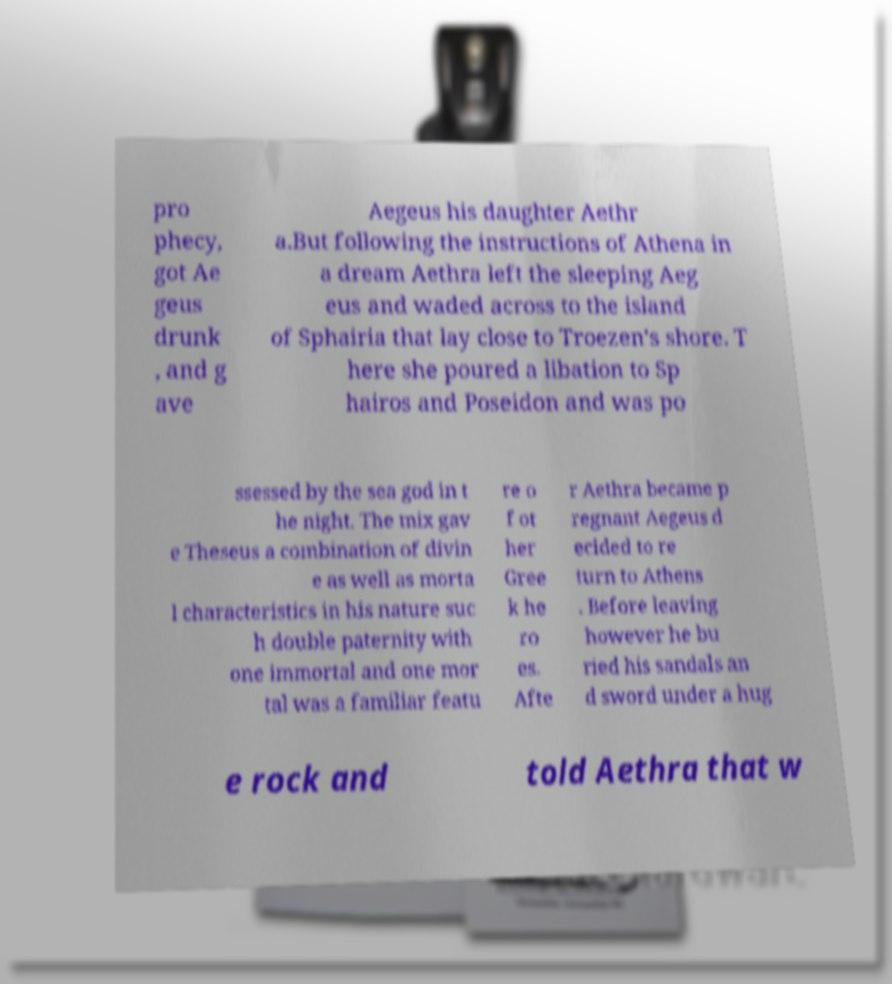What messages or text are displayed in this image? I need them in a readable, typed format. pro phecy, got Ae geus drunk , and g ave Aegeus his daughter Aethr a.But following the instructions of Athena in a dream Aethra left the sleeping Aeg eus and waded across to the island of Sphairia that lay close to Troezen's shore. T here she poured a libation to Sp hairos and Poseidon and was po ssessed by the sea god in t he night. The mix gav e Theseus a combination of divin e as well as morta l characteristics in his nature suc h double paternity with one immortal and one mor tal was a familiar featu re o f ot her Gree k he ro es. Afte r Aethra became p regnant Aegeus d ecided to re turn to Athens . Before leaving however he bu ried his sandals an d sword under a hug e rock and told Aethra that w 